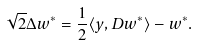<formula> <loc_0><loc_0><loc_500><loc_500>\sqrt { 2 } \Delta w ^ { * } = \frac { 1 } { 2 } \langle y , D w ^ { * } \rangle - w ^ { * } .</formula> 